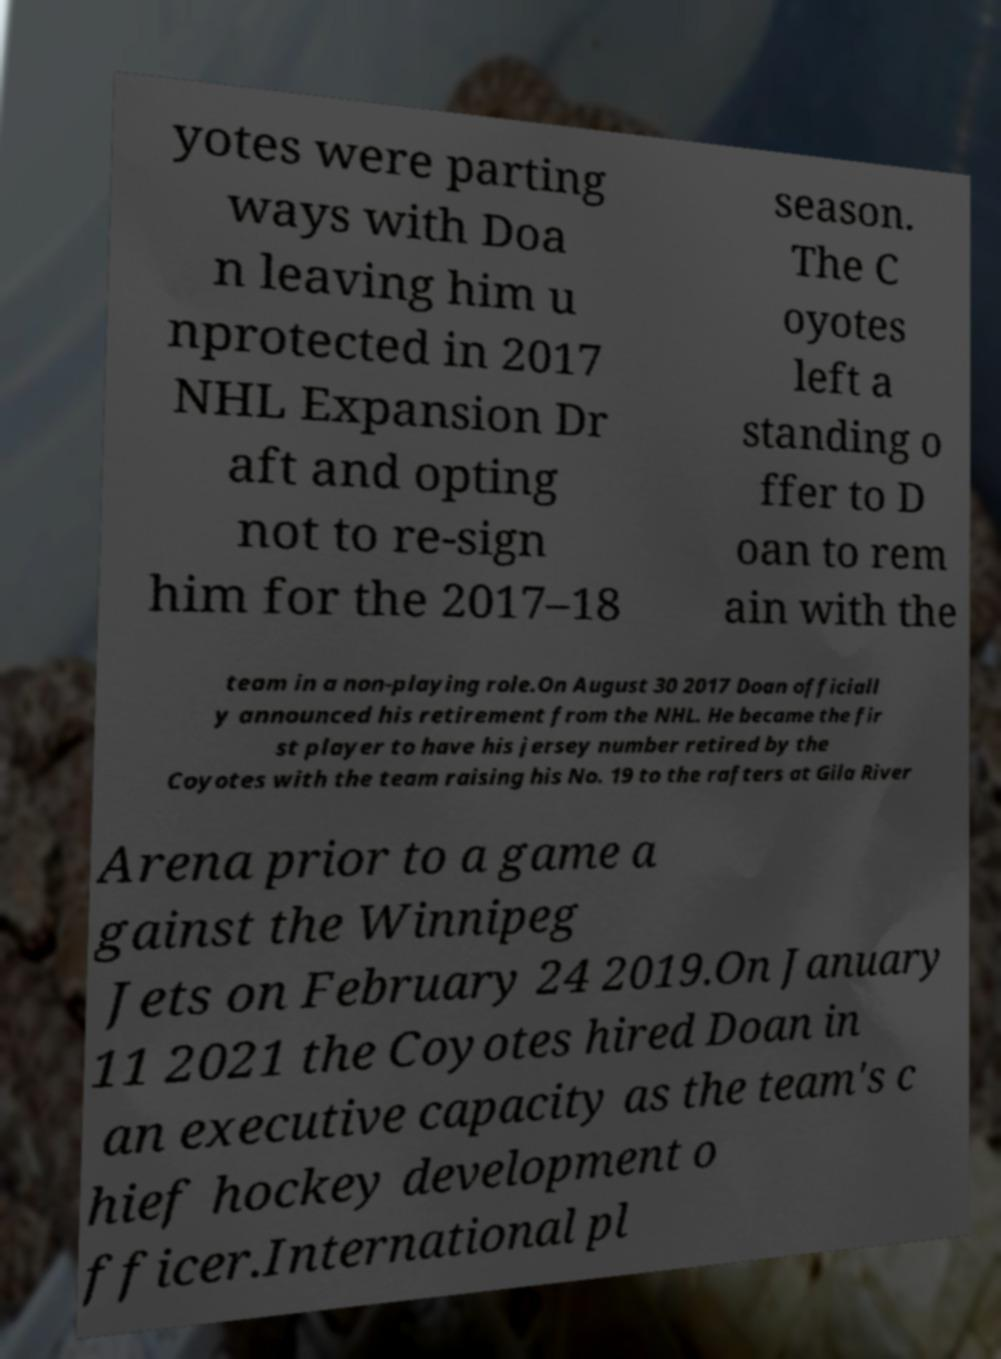For documentation purposes, I need the text within this image transcribed. Could you provide that? yotes were parting ways with Doa n leaving him u nprotected in 2017 NHL Expansion Dr aft and opting not to re-sign him for the 2017–18 season. The C oyotes left a standing o ffer to D oan to rem ain with the team in a non-playing role.On August 30 2017 Doan officiall y announced his retirement from the NHL. He became the fir st player to have his jersey number retired by the Coyotes with the team raising his No. 19 to the rafters at Gila River Arena prior to a game a gainst the Winnipeg Jets on February 24 2019.On January 11 2021 the Coyotes hired Doan in an executive capacity as the team's c hief hockey development o fficer.International pl 